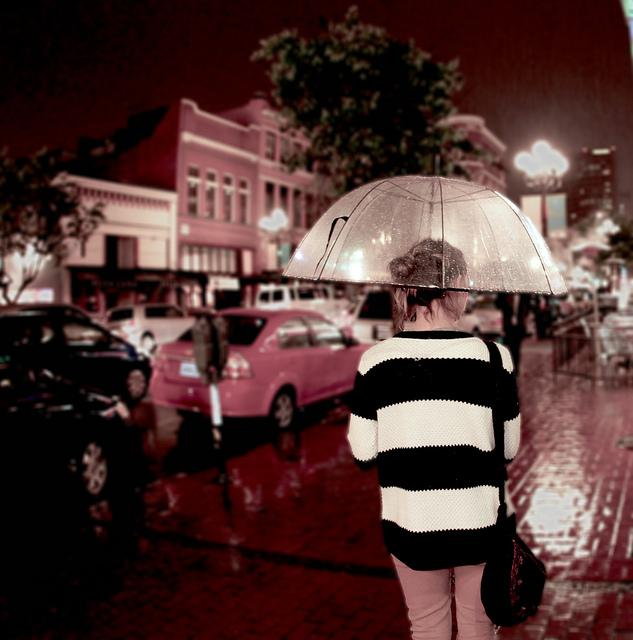Why is the woman using an umbrella? rain 